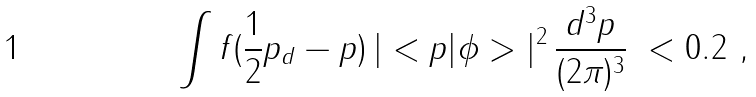Convert formula to latex. <formula><loc_0><loc_0><loc_500><loc_500>\int f ( \frac { 1 } { 2 } { p _ { d } } - { p } ) \, | < { p } | \phi > | ^ { 2 } \, \frac { d ^ { 3 } p } { ( 2 \pi ) ^ { 3 } } \ < 0 . 2 \ ,</formula> 